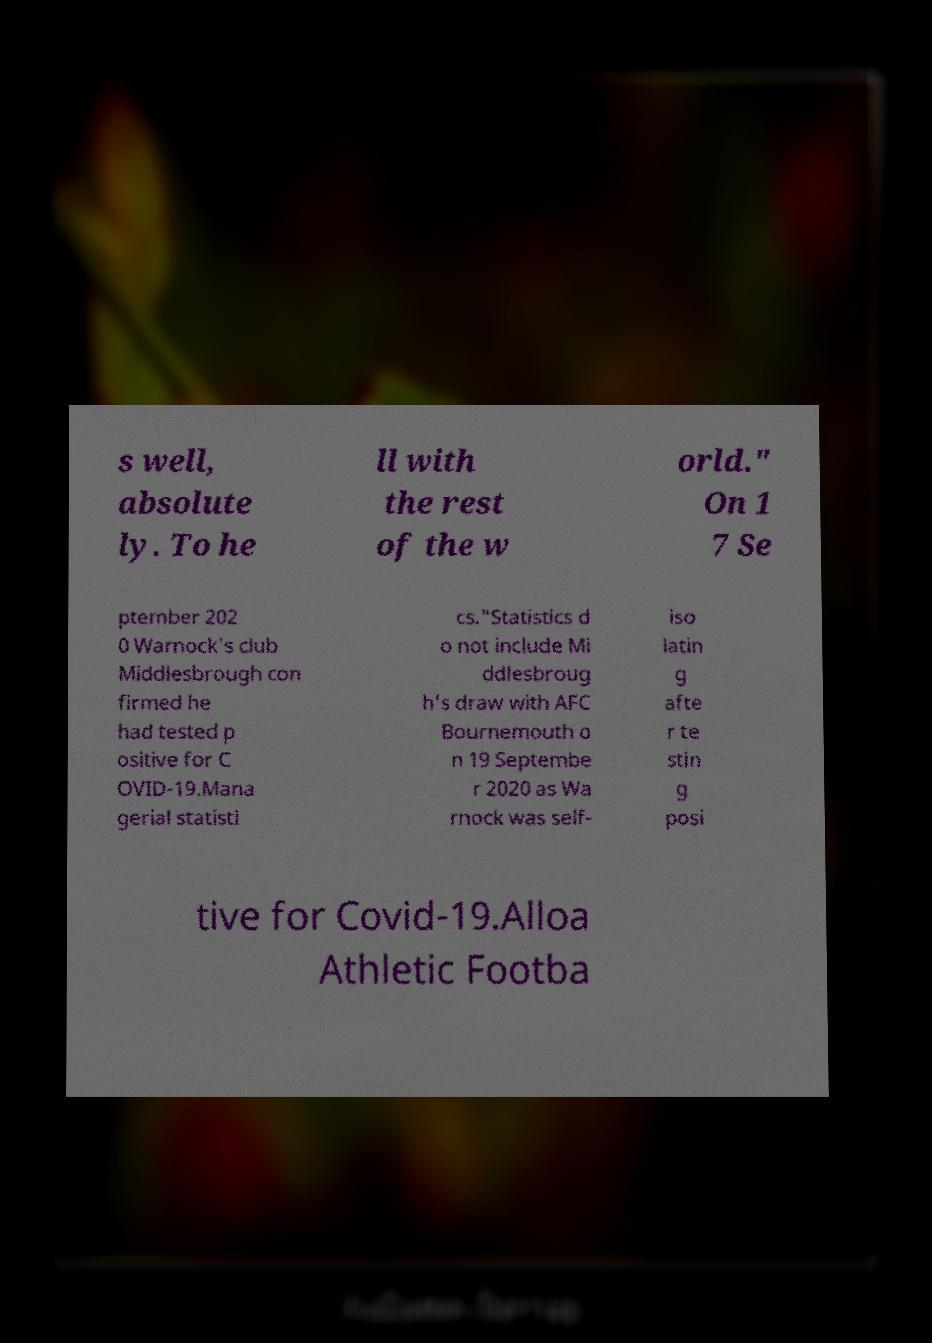Can you accurately transcribe the text from the provided image for me? s well, absolute ly. To he ll with the rest of the w orld." On 1 7 Se ptember 202 0 Warnock's club Middlesbrough con firmed he had tested p ositive for C OVID-19.Mana gerial statisti cs."Statistics d o not include Mi ddlesbroug h's draw with AFC Bournemouth o n 19 Septembe r 2020 as Wa rnock was self- iso latin g afte r te stin g posi tive for Covid-19.Alloa Athletic Footba 